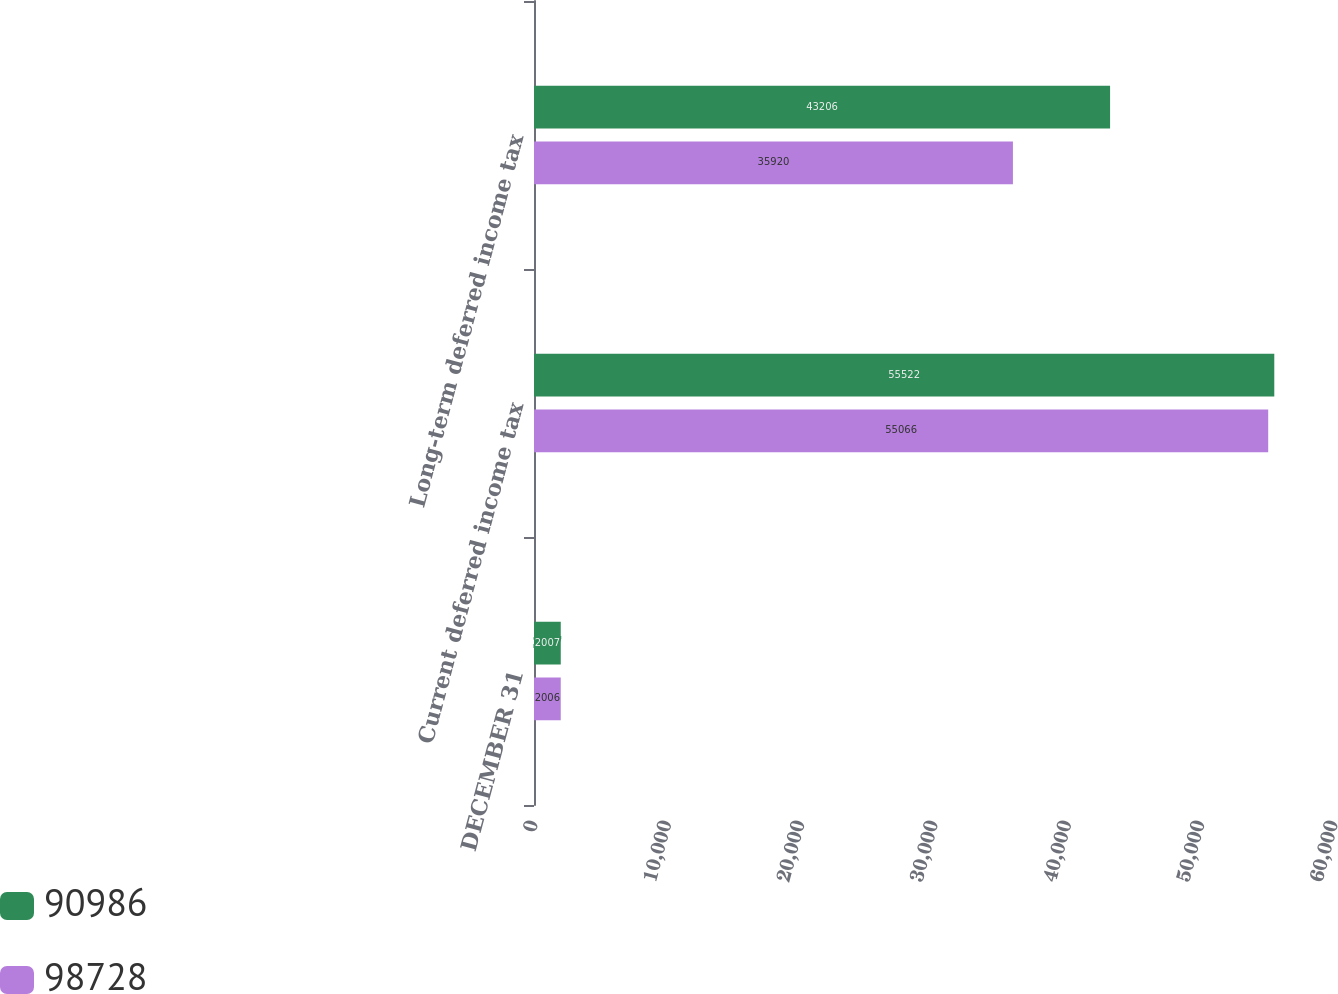<chart> <loc_0><loc_0><loc_500><loc_500><stacked_bar_chart><ecel><fcel>DECEMBER 31<fcel>Current deferred income tax<fcel>Long-term deferred income tax<nl><fcel>90986<fcel>2007<fcel>55522<fcel>43206<nl><fcel>98728<fcel>2006<fcel>55066<fcel>35920<nl></chart> 